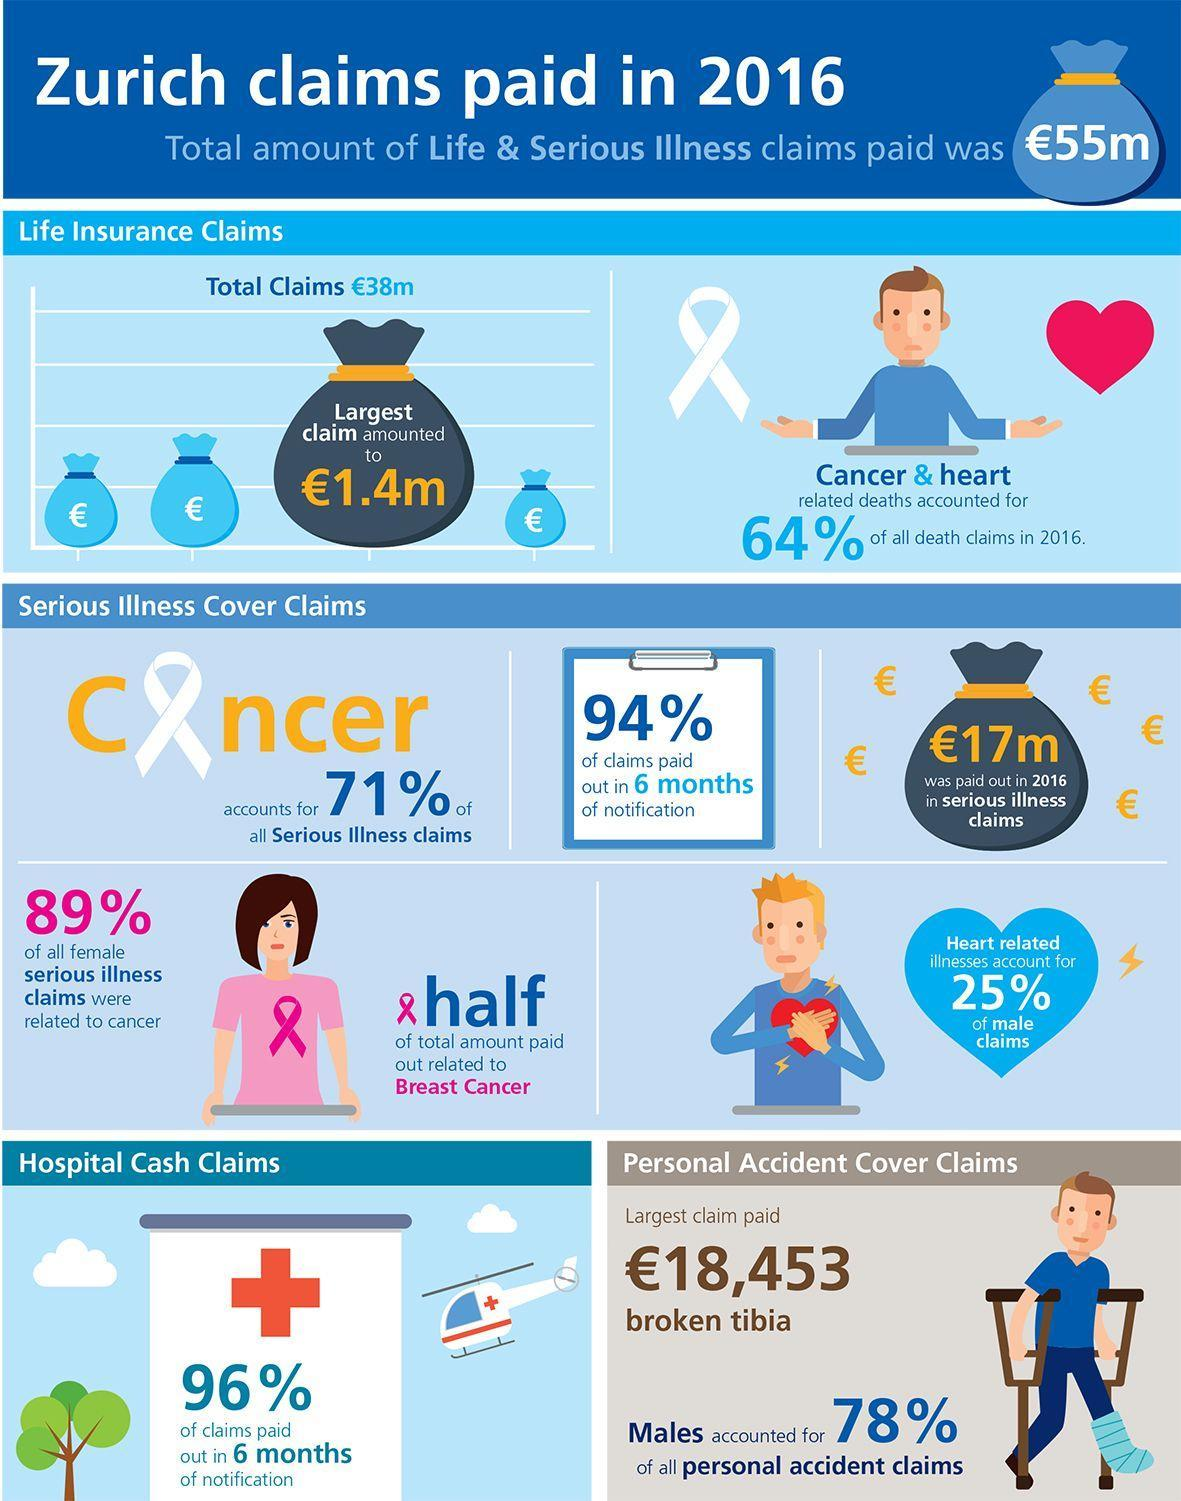For what was the largest claim paid in personal accident cover claims?
Answer the question with a short phrase. Broken Tibia What percentage of all female serious illness claims were not related to cancer? 11% 